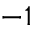Convert formula to latex. <formula><loc_0><loc_0><loc_500><loc_500>^ { - 1 }</formula> 